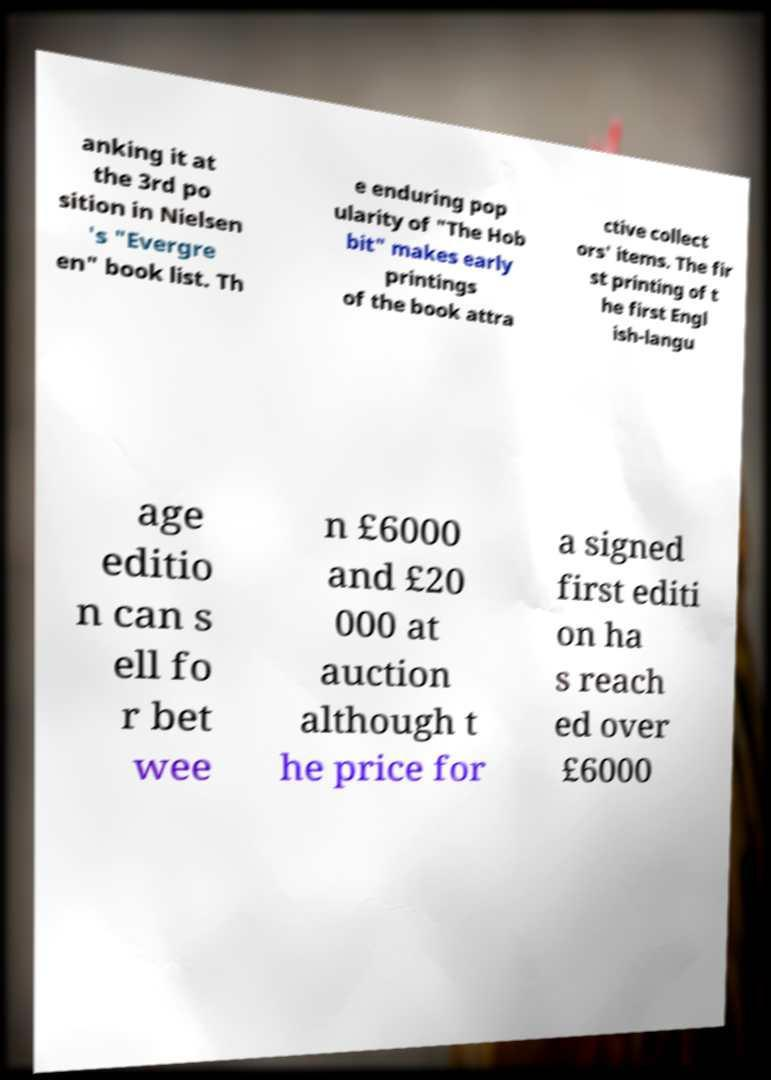Can you read and provide the text displayed in the image?This photo seems to have some interesting text. Can you extract and type it out for me? anking it at the 3rd po sition in Nielsen 's "Evergre en" book list. Th e enduring pop ularity of "The Hob bit" makes early printings of the book attra ctive collect ors' items. The fir st printing of t he first Engl ish-langu age editio n can s ell fo r bet wee n £6000 and £20 000 at auction although t he price for a signed first editi on ha s reach ed over £6000 